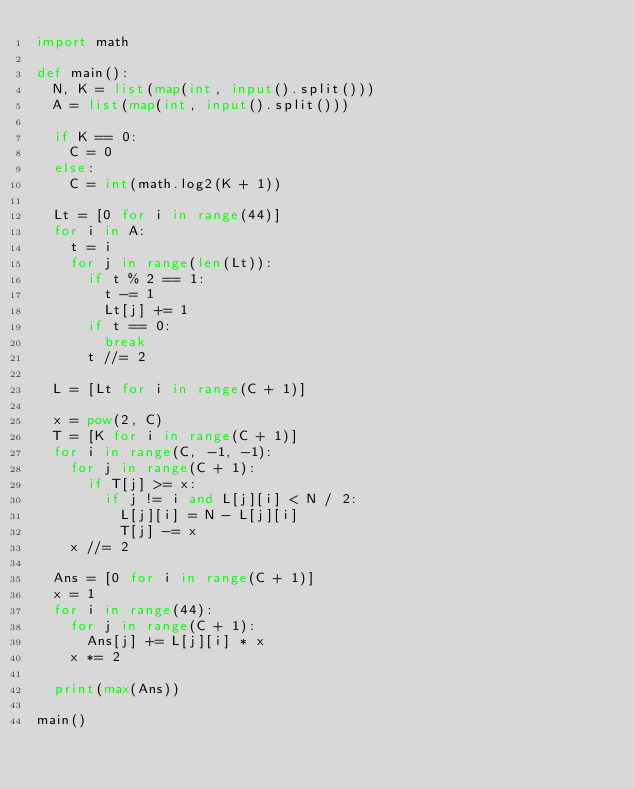Convert code to text. <code><loc_0><loc_0><loc_500><loc_500><_Python_>import math

def main():
  N, K = list(map(int, input().split()))
  A = list(map(int, input().split()))
  
  if K == 0:
    C = 0
  else:
    C = int(math.log2(K + 1))
  
  Lt = [0 for i in range(44)]
  for i in A:
    t = i
    for j in range(len(Lt)):
      if t % 2 == 1:
        t -= 1
        Lt[j] += 1
      if t == 0:
        break
      t //= 2
  
  L = [Lt for i in range(C + 1)]
  
  x = pow(2, C)
  T = [K for i in range(C + 1)]
  for i in range(C, -1, -1):
    for j in range(C + 1):
      if T[j] >= x:
        if j != i and L[j][i] < N / 2:
          L[j][i] = N - L[j][i]
          T[j] -= x
    x //= 2
  
  Ans = [0 for i in range(C + 1)]
  x = 1
  for i in range(44):
    for j in range(C + 1):
      Ans[j] += L[j][i] * x
    x *= 2
  
  print(max(Ans))
  
main()</code> 